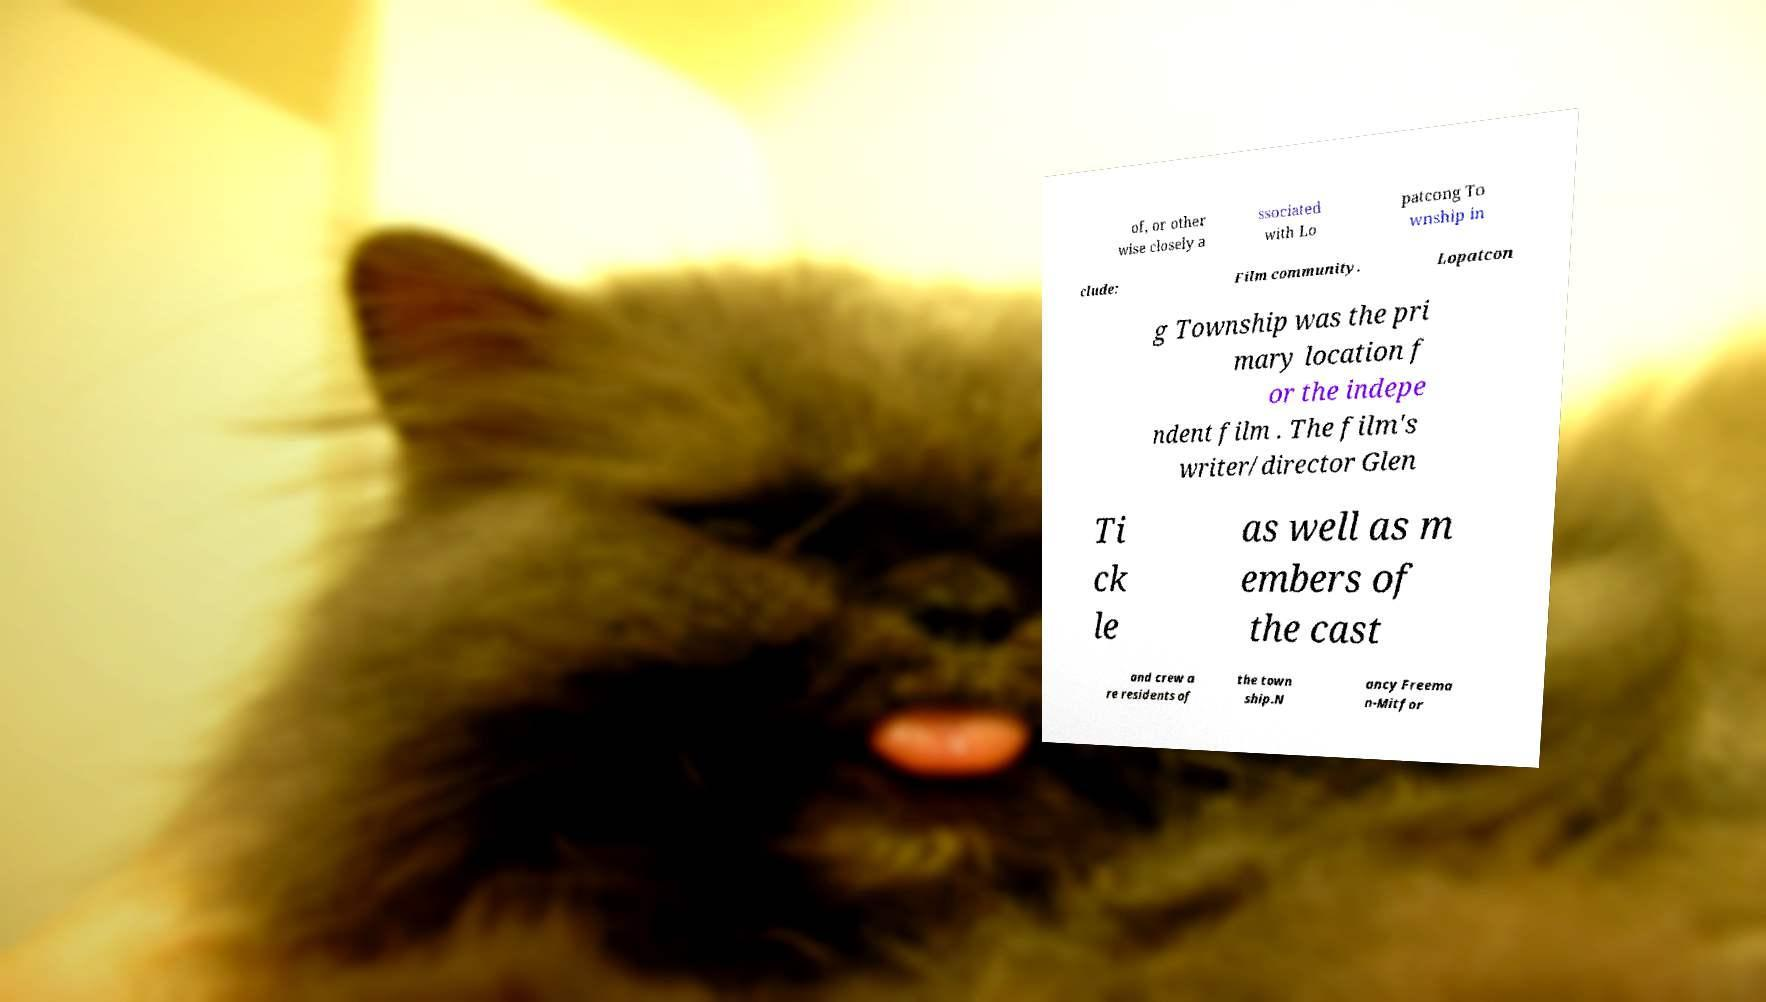Could you assist in decoding the text presented in this image and type it out clearly? of, or other wise closely a ssociated with Lo patcong To wnship in clude: Film community. Lopatcon g Township was the pri mary location f or the indepe ndent film . The film's writer/director Glen Ti ck le as well as m embers of the cast and crew a re residents of the town ship.N ancy Freema n-Mitfor 